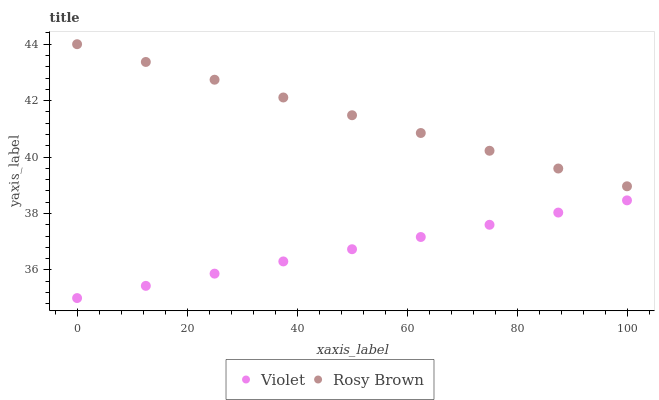Does Violet have the minimum area under the curve?
Answer yes or no. Yes. Does Rosy Brown have the maximum area under the curve?
Answer yes or no. Yes. Does Violet have the maximum area under the curve?
Answer yes or no. No. Is Rosy Brown the smoothest?
Answer yes or no. Yes. Is Violet the roughest?
Answer yes or no. Yes. Is Violet the smoothest?
Answer yes or no. No. Does Violet have the lowest value?
Answer yes or no. Yes. Does Rosy Brown have the highest value?
Answer yes or no. Yes. Does Violet have the highest value?
Answer yes or no. No. Is Violet less than Rosy Brown?
Answer yes or no. Yes. Is Rosy Brown greater than Violet?
Answer yes or no. Yes. Does Violet intersect Rosy Brown?
Answer yes or no. No. 